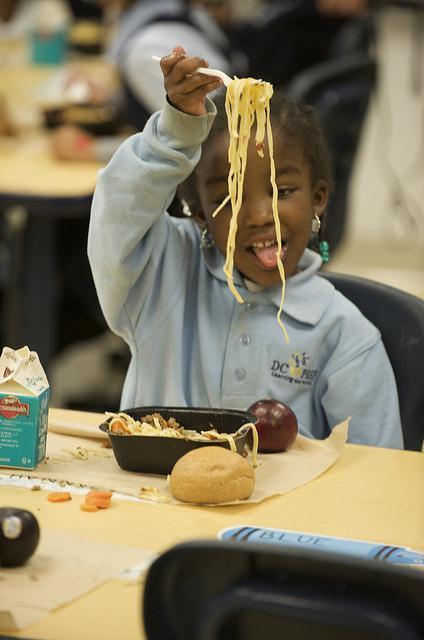How many people are there?
Give a very brief answer. 2. How many dining tables are in the picture?
Give a very brief answer. 2. How many chairs are there?
Give a very brief answer. 2. 